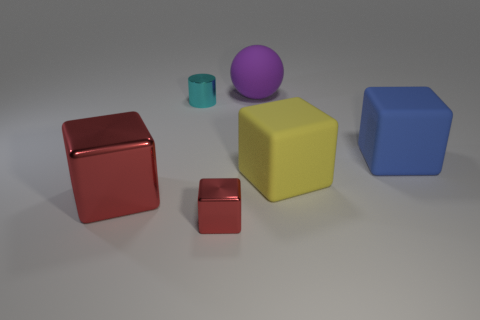There is a red cube that is to the left of the cube in front of the large red metallic block; how many large matte balls are left of it?
Provide a succinct answer. 0. Is there a small shiny thing of the same color as the big metallic block?
Your answer should be compact. Yes. The other shiny thing that is the same size as the cyan object is what color?
Make the answer very short. Red. The tiny shiny object that is in front of the big thing on the left side of the large rubber object behind the big blue rubber cube is what shape?
Provide a short and direct response. Cube. How many cyan cylinders are to the right of the red metallic block that is right of the cyan thing?
Provide a short and direct response. 0. Does the shiny object that is behind the big metal block have the same shape as the small shiny object in front of the yellow object?
Make the answer very short. No. There is a large purple sphere; how many large blocks are on the left side of it?
Your answer should be very brief. 1. Are the small thing behind the large blue object and the large purple thing made of the same material?
Make the answer very short. No. The other big metallic object that is the same shape as the large blue object is what color?
Keep it short and to the point. Red. There is a big purple matte object; what shape is it?
Your answer should be very brief. Sphere. 